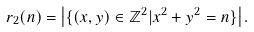<formula> <loc_0><loc_0><loc_500><loc_500>r _ { 2 } ( n ) = \left | \{ ( x , y ) \in \mathbb { Z } ^ { 2 } | x ^ { 2 } + y ^ { 2 } = n \} \right | .</formula> 